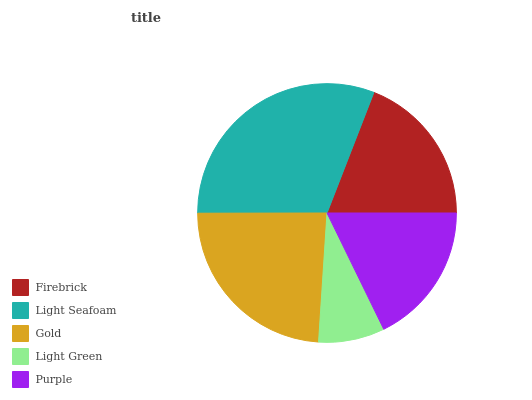Is Light Green the minimum?
Answer yes or no. Yes. Is Light Seafoam the maximum?
Answer yes or no. Yes. Is Gold the minimum?
Answer yes or no. No. Is Gold the maximum?
Answer yes or no. No. Is Light Seafoam greater than Gold?
Answer yes or no. Yes. Is Gold less than Light Seafoam?
Answer yes or no. Yes. Is Gold greater than Light Seafoam?
Answer yes or no. No. Is Light Seafoam less than Gold?
Answer yes or no. No. Is Firebrick the high median?
Answer yes or no. Yes. Is Firebrick the low median?
Answer yes or no. Yes. Is Purple the high median?
Answer yes or no. No. Is Light Green the low median?
Answer yes or no. No. 